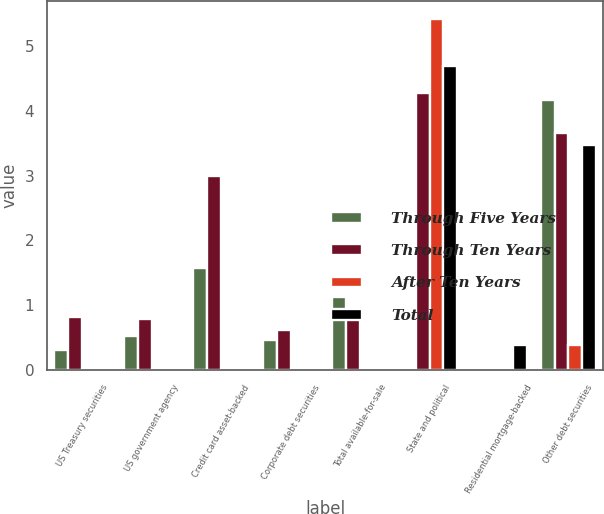<chart> <loc_0><loc_0><loc_500><loc_500><stacked_bar_chart><ecel><fcel>US Treasury securities<fcel>US government agency<fcel>Credit card asset-backed<fcel>Corporate debt securities<fcel>Total available-for-sale<fcel>State and political<fcel>Residential mortgage-backed<fcel>Other debt securities<nl><fcel>Through Five Years<fcel>0.31<fcel>0.53<fcel>1.58<fcel>0.46<fcel>1.12<fcel>0<fcel>0<fcel>4.17<nl><fcel>Through Ten Years<fcel>0.82<fcel>0.78<fcel>3<fcel>0.62<fcel>0.93<fcel>4.27<fcel>0<fcel>3.65<nl><fcel>After Ten Years<fcel>0<fcel>0<fcel>0<fcel>0<fcel>0<fcel>5.42<fcel>0<fcel>0.385<nl><fcel>Total<fcel>0<fcel>0<fcel>0<fcel>0<fcel>0<fcel>4.69<fcel>0.385<fcel>3.47<nl></chart> 